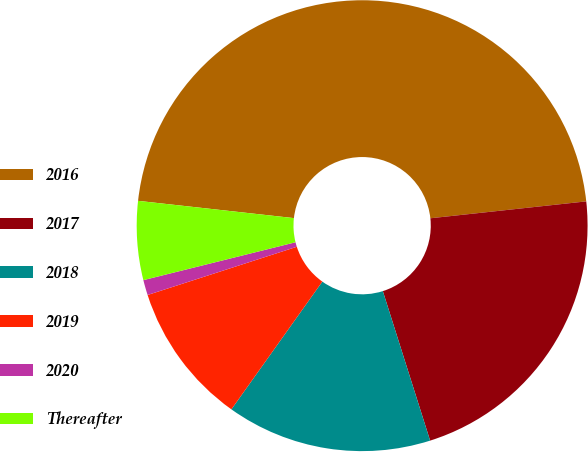<chart> <loc_0><loc_0><loc_500><loc_500><pie_chart><fcel>2016<fcel>2017<fcel>2018<fcel>2019<fcel>2020<fcel>Thereafter<nl><fcel>46.52%<fcel>21.84%<fcel>14.72%<fcel>10.18%<fcel>1.09%<fcel>5.64%<nl></chart> 